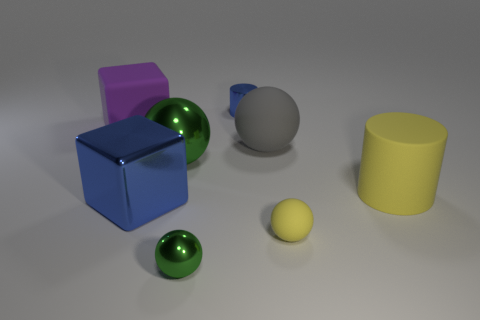Are there any other things of the same color as the big rubber ball?
Provide a succinct answer. No. What shape is the rubber object that is on the left side of the small yellow matte thing and on the right side of the big shiny cube?
Provide a short and direct response. Sphere. Do the metallic cylinder and the large block that is on the right side of the large purple object have the same color?
Make the answer very short. Yes. There is a matte thing behind the gray sphere; is it the same size as the big gray thing?
Your answer should be compact. Yes. What is the material of the gray object that is the same shape as the small yellow rubber object?
Keep it short and to the point. Rubber. Is the tiny blue metallic object the same shape as the large yellow thing?
Give a very brief answer. Yes. How many small blue cylinders are left of the blue metal object in front of the large gray sphere?
Make the answer very short. 0. What is the shape of the other tiny object that is the same material as the small green object?
Your response must be concise. Cylinder. How many green objects are either large blocks or big shiny objects?
Make the answer very short. 1. There is a blue object in front of the green shiny thing that is behind the tiny green metallic sphere; is there a large gray matte thing left of it?
Give a very brief answer. No. 